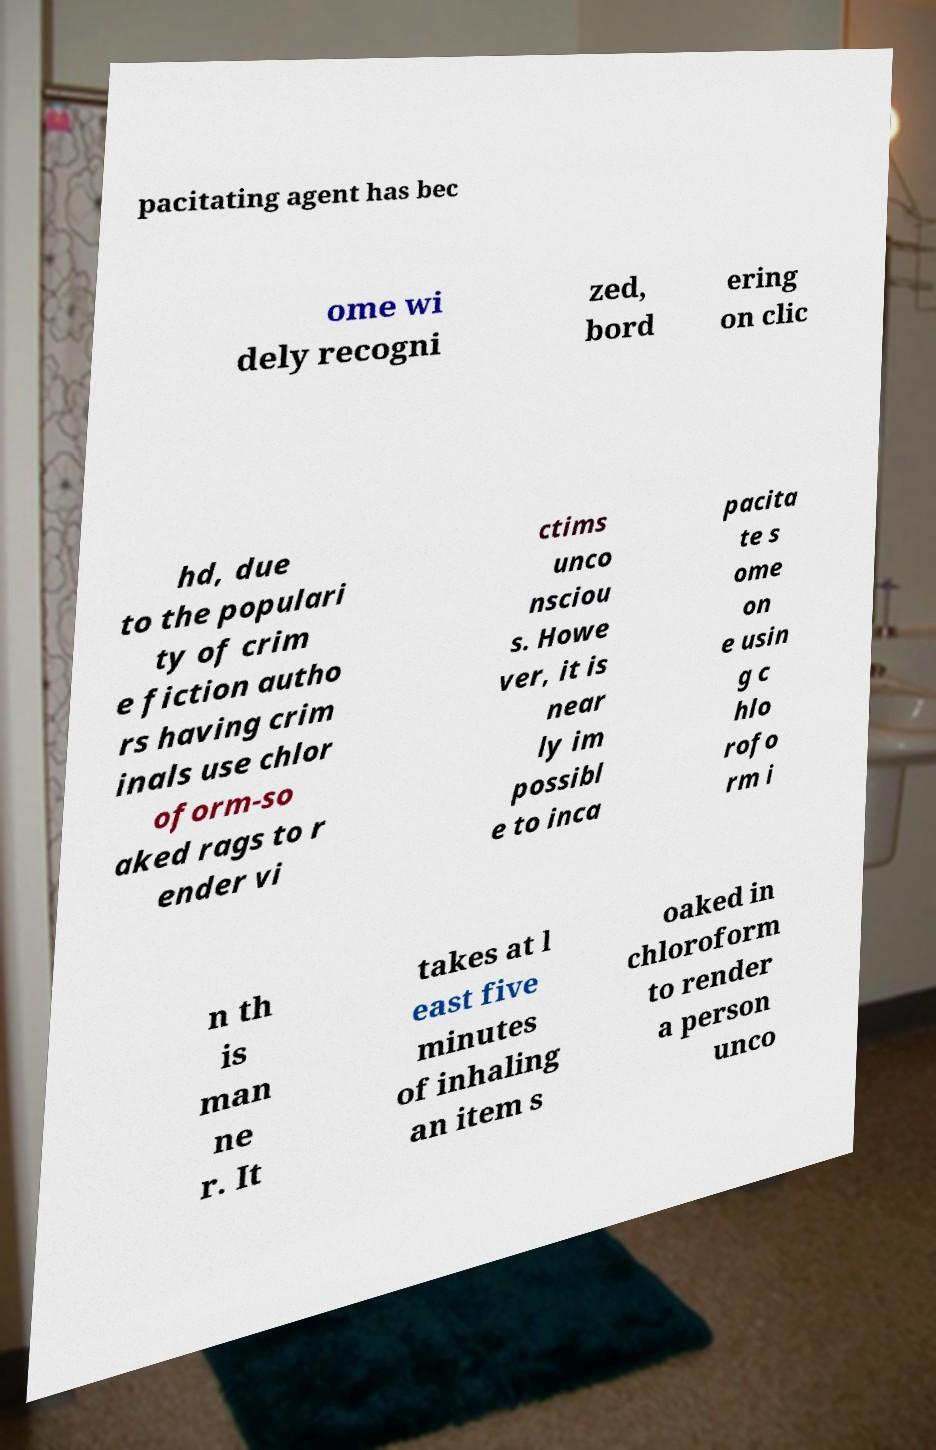What messages or text are displayed in this image? I need them in a readable, typed format. pacitating agent has bec ome wi dely recogni zed, bord ering on clic hd, due to the populari ty of crim e fiction autho rs having crim inals use chlor oform-so aked rags to r ender vi ctims unco nsciou s. Howe ver, it is near ly im possibl e to inca pacita te s ome on e usin g c hlo rofo rm i n th is man ne r. It takes at l east five minutes of inhaling an item s oaked in chloroform to render a person unco 